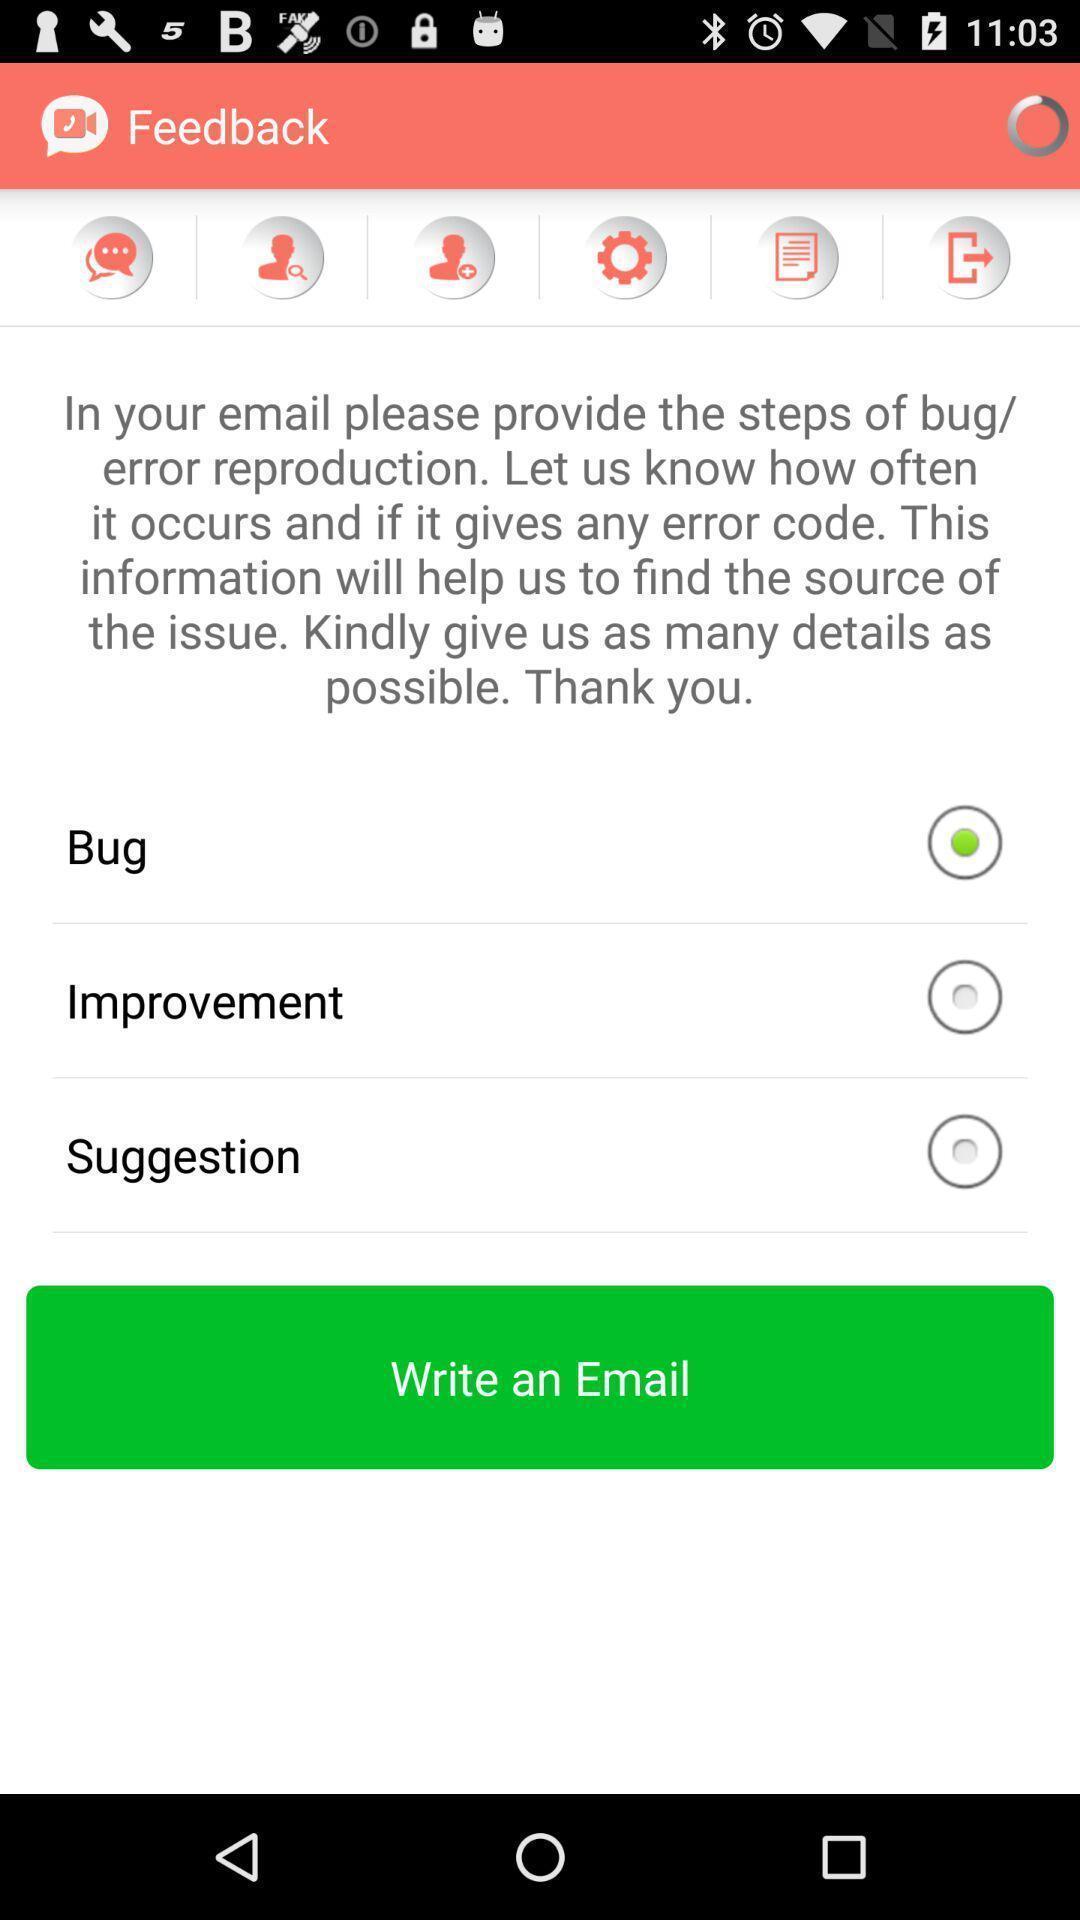What can you discern from this picture? Page showing feedback on an app. 